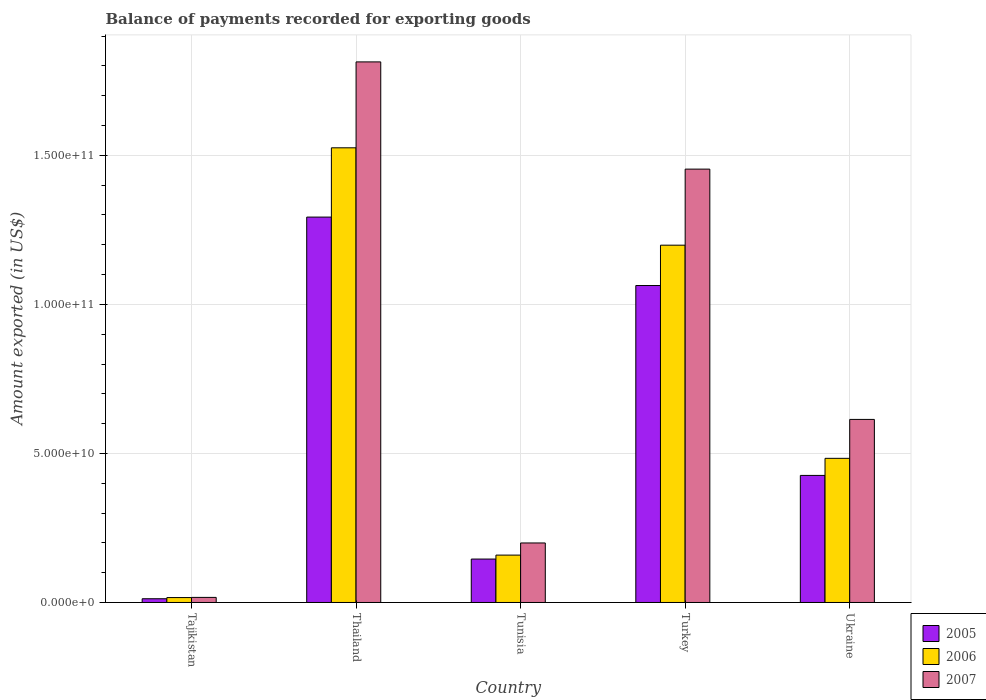How many groups of bars are there?
Offer a very short reply. 5. Are the number of bars on each tick of the X-axis equal?
Your answer should be compact. Yes. How many bars are there on the 1st tick from the left?
Offer a terse response. 3. How many bars are there on the 5th tick from the right?
Your answer should be very brief. 3. What is the label of the 4th group of bars from the left?
Offer a terse response. Turkey. What is the amount exported in 2006 in Tunisia?
Your answer should be compact. 1.59e+1. Across all countries, what is the maximum amount exported in 2007?
Offer a terse response. 1.81e+11. Across all countries, what is the minimum amount exported in 2005?
Your answer should be very brief. 1.25e+09. In which country was the amount exported in 2006 maximum?
Ensure brevity in your answer.  Thailand. In which country was the amount exported in 2007 minimum?
Make the answer very short. Tajikistan. What is the total amount exported in 2005 in the graph?
Give a very brief answer. 2.94e+11. What is the difference between the amount exported in 2005 in Thailand and that in Ukraine?
Keep it short and to the point. 8.67e+1. What is the difference between the amount exported in 2006 in Ukraine and the amount exported in 2007 in Tunisia?
Give a very brief answer. 2.84e+1. What is the average amount exported in 2006 per country?
Offer a very short reply. 6.77e+1. What is the difference between the amount exported of/in 2007 and amount exported of/in 2005 in Thailand?
Your answer should be compact. 5.21e+1. In how many countries, is the amount exported in 2006 greater than 40000000000 US$?
Give a very brief answer. 3. What is the ratio of the amount exported in 2006 in Tunisia to that in Ukraine?
Provide a succinct answer. 0.33. Is the difference between the amount exported in 2007 in Tajikistan and Tunisia greater than the difference between the amount exported in 2005 in Tajikistan and Tunisia?
Ensure brevity in your answer.  No. What is the difference between the highest and the second highest amount exported in 2006?
Provide a succinct answer. 3.27e+1. What is the difference between the highest and the lowest amount exported in 2006?
Your answer should be compact. 1.51e+11. In how many countries, is the amount exported in 2005 greater than the average amount exported in 2005 taken over all countries?
Keep it short and to the point. 2. What does the 2nd bar from the left in Turkey represents?
Your answer should be very brief. 2006. What does the 2nd bar from the right in Thailand represents?
Keep it short and to the point. 2006. How many countries are there in the graph?
Your answer should be compact. 5. Are the values on the major ticks of Y-axis written in scientific E-notation?
Offer a terse response. Yes. How many legend labels are there?
Your answer should be very brief. 3. What is the title of the graph?
Provide a succinct answer. Balance of payments recorded for exporting goods. What is the label or title of the Y-axis?
Your answer should be compact. Amount exported (in US$). What is the Amount exported (in US$) of 2005 in Tajikistan?
Keep it short and to the point. 1.25e+09. What is the Amount exported (in US$) in 2006 in Tajikistan?
Offer a very short reply. 1.65e+09. What is the Amount exported (in US$) in 2007 in Tajikistan?
Give a very brief answer. 1.71e+09. What is the Amount exported (in US$) in 2005 in Thailand?
Provide a succinct answer. 1.29e+11. What is the Amount exported (in US$) in 2006 in Thailand?
Provide a succinct answer. 1.53e+11. What is the Amount exported (in US$) in 2007 in Thailand?
Provide a short and direct response. 1.81e+11. What is the Amount exported (in US$) in 2005 in Tunisia?
Your response must be concise. 1.46e+1. What is the Amount exported (in US$) in 2006 in Tunisia?
Make the answer very short. 1.59e+1. What is the Amount exported (in US$) of 2007 in Tunisia?
Offer a very short reply. 2.00e+1. What is the Amount exported (in US$) of 2005 in Turkey?
Keep it short and to the point. 1.06e+11. What is the Amount exported (in US$) of 2006 in Turkey?
Offer a terse response. 1.20e+11. What is the Amount exported (in US$) in 2007 in Turkey?
Provide a short and direct response. 1.45e+11. What is the Amount exported (in US$) in 2005 in Ukraine?
Ensure brevity in your answer.  4.26e+1. What is the Amount exported (in US$) in 2006 in Ukraine?
Ensure brevity in your answer.  4.84e+1. What is the Amount exported (in US$) in 2007 in Ukraine?
Ensure brevity in your answer.  6.14e+1. Across all countries, what is the maximum Amount exported (in US$) of 2005?
Provide a succinct answer. 1.29e+11. Across all countries, what is the maximum Amount exported (in US$) of 2006?
Offer a very short reply. 1.53e+11. Across all countries, what is the maximum Amount exported (in US$) in 2007?
Your response must be concise. 1.81e+11. Across all countries, what is the minimum Amount exported (in US$) in 2005?
Offer a terse response. 1.25e+09. Across all countries, what is the minimum Amount exported (in US$) of 2006?
Offer a terse response. 1.65e+09. Across all countries, what is the minimum Amount exported (in US$) of 2007?
Provide a short and direct response. 1.71e+09. What is the total Amount exported (in US$) of 2005 in the graph?
Offer a very short reply. 2.94e+11. What is the total Amount exported (in US$) in 2006 in the graph?
Your response must be concise. 3.38e+11. What is the total Amount exported (in US$) in 2007 in the graph?
Offer a very short reply. 4.10e+11. What is the difference between the Amount exported (in US$) of 2005 in Tajikistan and that in Thailand?
Provide a succinct answer. -1.28e+11. What is the difference between the Amount exported (in US$) in 2006 in Tajikistan and that in Thailand?
Provide a short and direct response. -1.51e+11. What is the difference between the Amount exported (in US$) of 2007 in Tajikistan and that in Thailand?
Make the answer very short. -1.80e+11. What is the difference between the Amount exported (in US$) of 2005 in Tajikistan and that in Tunisia?
Keep it short and to the point. -1.33e+1. What is the difference between the Amount exported (in US$) of 2006 in Tajikistan and that in Tunisia?
Make the answer very short. -1.42e+1. What is the difference between the Amount exported (in US$) of 2007 in Tajikistan and that in Tunisia?
Keep it short and to the point. -1.83e+1. What is the difference between the Amount exported (in US$) in 2005 in Tajikistan and that in Turkey?
Your answer should be compact. -1.05e+11. What is the difference between the Amount exported (in US$) in 2006 in Tajikistan and that in Turkey?
Your answer should be very brief. -1.18e+11. What is the difference between the Amount exported (in US$) of 2007 in Tajikistan and that in Turkey?
Offer a very short reply. -1.44e+11. What is the difference between the Amount exported (in US$) in 2005 in Tajikistan and that in Ukraine?
Provide a succinct answer. -4.14e+1. What is the difference between the Amount exported (in US$) of 2006 in Tajikistan and that in Ukraine?
Your answer should be very brief. -4.67e+1. What is the difference between the Amount exported (in US$) in 2007 in Tajikistan and that in Ukraine?
Provide a succinct answer. -5.97e+1. What is the difference between the Amount exported (in US$) in 2005 in Thailand and that in Tunisia?
Offer a very short reply. 1.15e+11. What is the difference between the Amount exported (in US$) of 2006 in Thailand and that in Tunisia?
Your answer should be compact. 1.37e+11. What is the difference between the Amount exported (in US$) of 2007 in Thailand and that in Tunisia?
Provide a succinct answer. 1.61e+11. What is the difference between the Amount exported (in US$) in 2005 in Thailand and that in Turkey?
Offer a very short reply. 2.30e+1. What is the difference between the Amount exported (in US$) of 2006 in Thailand and that in Turkey?
Give a very brief answer. 3.27e+1. What is the difference between the Amount exported (in US$) of 2007 in Thailand and that in Turkey?
Give a very brief answer. 3.60e+1. What is the difference between the Amount exported (in US$) in 2005 in Thailand and that in Ukraine?
Provide a short and direct response. 8.67e+1. What is the difference between the Amount exported (in US$) of 2006 in Thailand and that in Ukraine?
Offer a terse response. 1.04e+11. What is the difference between the Amount exported (in US$) in 2007 in Thailand and that in Ukraine?
Give a very brief answer. 1.20e+11. What is the difference between the Amount exported (in US$) in 2005 in Tunisia and that in Turkey?
Your response must be concise. -9.18e+1. What is the difference between the Amount exported (in US$) of 2006 in Tunisia and that in Turkey?
Provide a short and direct response. -1.04e+11. What is the difference between the Amount exported (in US$) in 2007 in Tunisia and that in Turkey?
Give a very brief answer. -1.25e+11. What is the difference between the Amount exported (in US$) of 2005 in Tunisia and that in Ukraine?
Your answer should be compact. -2.81e+1. What is the difference between the Amount exported (in US$) of 2006 in Tunisia and that in Ukraine?
Offer a terse response. -3.25e+1. What is the difference between the Amount exported (in US$) of 2007 in Tunisia and that in Ukraine?
Provide a short and direct response. -4.14e+1. What is the difference between the Amount exported (in US$) in 2005 in Turkey and that in Ukraine?
Offer a terse response. 6.37e+1. What is the difference between the Amount exported (in US$) of 2006 in Turkey and that in Ukraine?
Your response must be concise. 7.15e+1. What is the difference between the Amount exported (in US$) of 2007 in Turkey and that in Ukraine?
Give a very brief answer. 8.40e+1. What is the difference between the Amount exported (in US$) of 2005 in Tajikistan and the Amount exported (in US$) of 2006 in Thailand?
Your answer should be compact. -1.51e+11. What is the difference between the Amount exported (in US$) of 2005 in Tajikistan and the Amount exported (in US$) of 2007 in Thailand?
Ensure brevity in your answer.  -1.80e+11. What is the difference between the Amount exported (in US$) of 2006 in Tajikistan and the Amount exported (in US$) of 2007 in Thailand?
Provide a succinct answer. -1.80e+11. What is the difference between the Amount exported (in US$) in 2005 in Tajikistan and the Amount exported (in US$) in 2006 in Tunisia?
Your response must be concise. -1.46e+1. What is the difference between the Amount exported (in US$) of 2005 in Tajikistan and the Amount exported (in US$) of 2007 in Tunisia?
Ensure brevity in your answer.  -1.87e+1. What is the difference between the Amount exported (in US$) of 2006 in Tajikistan and the Amount exported (in US$) of 2007 in Tunisia?
Ensure brevity in your answer.  -1.83e+1. What is the difference between the Amount exported (in US$) in 2005 in Tajikistan and the Amount exported (in US$) in 2006 in Turkey?
Give a very brief answer. -1.19e+11. What is the difference between the Amount exported (in US$) of 2005 in Tajikistan and the Amount exported (in US$) of 2007 in Turkey?
Keep it short and to the point. -1.44e+11. What is the difference between the Amount exported (in US$) of 2006 in Tajikistan and the Amount exported (in US$) of 2007 in Turkey?
Keep it short and to the point. -1.44e+11. What is the difference between the Amount exported (in US$) in 2005 in Tajikistan and the Amount exported (in US$) in 2006 in Ukraine?
Your response must be concise. -4.71e+1. What is the difference between the Amount exported (in US$) of 2005 in Tajikistan and the Amount exported (in US$) of 2007 in Ukraine?
Offer a terse response. -6.02e+1. What is the difference between the Amount exported (in US$) in 2006 in Tajikistan and the Amount exported (in US$) in 2007 in Ukraine?
Your response must be concise. -5.98e+1. What is the difference between the Amount exported (in US$) of 2005 in Thailand and the Amount exported (in US$) of 2006 in Tunisia?
Your response must be concise. 1.13e+11. What is the difference between the Amount exported (in US$) of 2005 in Thailand and the Amount exported (in US$) of 2007 in Tunisia?
Your response must be concise. 1.09e+11. What is the difference between the Amount exported (in US$) of 2006 in Thailand and the Amount exported (in US$) of 2007 in Tunisia?
Your answer should be very brief. 1.33e+11. What is the difference between the Amount exported (in US$) of 2005 in Thailand and the Amount exported (in US$) of 2006 in Turkey?
Keep it short and to the point. 9.43e+09. What is the difference between the Amount exported (in US$) in 2005 in Thailand and the Amount exported (in US$) in 2007 in Turkey?
Provide a succinct answer. -1.61e+1. What is the difference between the Amount exported (in US$) in 2006 in Thailand and the Amount exported (in US$) in 2007 in Turkey?
Ensure brevity in your answer.  7.15e+09. What is the difference between the Amount exported (in US$) in 2005 in Thailand and the Amount exported (in US$) in 2006 in Ukraine?
Offer a terse response. 8.09e+1. What is the difference between the Amount exported (in US$) of 2005 in Thailand and the Amount exported (in US$) of 2007 in Ukraine?
Give a very brief answer. 6.79e+1. What is the difference between the Amount exported (in US$) of 2006 in Thailand and the Amount exported (in US$) of 2007 in Ukraine?
Your response must be concise. 9.11e+1. What is the difference between the Amount exported (in US$) in 2005 in Tunisia and the Amount exported (in US$) in 2006 in Turkey?
Provide a succinct answer. -1.05e+11. What is the difference between the Amount exported (in US$) in 2005 in Tunisia and the Amount exported (in US$) in 2007 in Turkey?
Your answer should be compact. -1.31e+11. What is the difference between the Amount exported (in US$) in 2006 in Tunisia and the Amount exported (in US$) in 2007 in Turkey?
Your answer should be very brief. -1.29e+11. What is the difference between the Amount exported (in US$) in 2005 in Tunisia and the Amount exported (in US$) in 2006 in Ukraine?
Your answer should be very brief. -3.38e+1. What is the difference between the Amount exported (in US$) of 2005 in Tunisia and the Amount exported (in US$) of 2007 in Ukraine?
Give a very brief answer. -4.68e+1. What is the difference between the Amount exported (in US$) of 2006 in Tunisia and the Amount exported (in US$) of 2007 in Ukraine?
Provide a succinct answer. -4.55e+1. What is the difference between the Amount exported (in US$) of 2005 in Turkey and the Amount exported (in US$) of 2006 in Ukraine?
Offer a very short reply. 5.80e+1. What is the difference between the Amount exported (in US$) in 2005 in Turkey and the Amount exported (in US$) in 2007 in Ukraine?
Provide a short and direct response. 4.49e+1. What is the difference between the Amount exported (in US$) of 2006 in Turkey and the Amount exported (in US$) of 2007 in Ukraine?
Make the answer very short. 5.85e+1. What is the average Amount exported (in US$) of 2005 per country?
Your answer should be very brief. 5.88e+1. What is the average Amount exported (in US$) of 2006 per country?
Keep it short and to the point. 6.77e+1. What is the average Amount exported (in US$) in 2007 per country?
Ensure brevity in your answer.  8.20e+1. What is the difference between the Amount exported (in US$) of 2005 and Amount exported (in US$) of 2006 in Tajikistan?
Give a very brief answer. -3.92e+08. What is the difference between the Amount exported (in US$) in 2005 and Amount exported (in US$) in 2007 in Tajikistan?
Provide a succinct answer. -4.51e+08. What is the difference between the Amount exported (in US$) in 2006 and Amount exported (in US$) in 2007 in Tajikistan?
Provide a succinct answer. -5.96e+07. What is the difference between the Amount exported (in US$) in 2005 and Amount exported (in US$) in 2006 in Thailand?
Make the answer very short. -2.32e+1. What is the difference between the Amount exported (in US$) of 2005 and Amount exported (in US$) of 2007 in Thailand?
Your answer should be very brief. -5.21e+1. What is the difference between the Amount exported (in US$) in 2006 and Amount exported (in US$) in 2007 in Thailand?
Your answer should be very brief. -2.88e+1. What is the difference between the Amount exported (in US$) in 2005 and Amount exported (in US$) in 2006 in Tunisia?
Keep it short and to the point. -1.32e+09. What is the difference between the Amount exported (in US$) in 2005 and Amount exported (in US$) in 2007 in Tunisia?
Your response must be concise. -5.40e+09. What is the difference between the Amount exported (in US$) in 2006 and Amount exported (in US$) in 2007 in Tunisia?
Keep it short and to the point. -4.07e+09. What is the difference between the Amount exported (in US$) of 2005 and Amount exported (in US$) of 2006 in Turkey?
Keep it short and to the point. -1.35e+1. What is the difference between the Amount exported (in US$) in 2005 and Amount exported (in US$) in 2007 in Turkey?
Give a very brief answer. -3.91e+1. What is the difference between the Amount exported (in US$) in 2006 and Amount exported (in US$) in 2007 in Turkey?
Provide a short and direct response. -2.55e+1. What is the difference between the Amount exported (in US$) in 2005 and Amount exported (in US$) in 2006 in Ukraine?
Ensure brevity in your answer.  -5.73e+09. What is the difference between the Amount exported (in US$) of 2005 and Amount exported (in US$) of 2007 in Ukraine?
Your answer should be compact. -1.88e+1. What is the difference between the Amount exported (in US$) in 2006 and Amount exported (in US$) in 2007 in Ukraine?
Your answer should be very brief. -1.31e+1. What is the ratio of the Amount exported (in US$) in 2005 in Tajikistan to that in Thailand?
Your answer should be compact. 0.01. What is the ratio of the Amount exported (in US$) of 2006 in Tajikistan to that in Thailand?
Offer a very short reply. 0.01. What is the ratio of the Amount exported (in US$) of 2007 in Tajikistan to that in Thailand?
Keep it short and to the point. 0.01. What is the ratio of the Amount exported (in US$) in 2005 in Tajikistan to that in Tunisia?
Keep it short and to the point. 0.09. What is the ratio of the Amount exported (in US$) in 2006 in Tajikistan to that in Tunisia?
Keep it short and to the point. 0.1. What is the ratio of the Amount exported (in US$) in 2007 in Tajikistan to that in Tunisia?
Make the answer very short. 0.09. What is the ratio of the Amount exported (in US$) of 2005 in Tajikistan to that in Turkey?
Your response must be concise. 0.01. What is the ratio of the Amount exported (in US$) in 2006 in Tajikistan to that in Turkey?
Give a very brief answer. 0.01. What is the ratio of the Amount exported (in US$) of 2007 in Tajikistan to that in Turkey?
Offer a very short reply. 0.01. What is the ratio of the Amount exported (in US$) in 2005 in Tajikistan to that in Ukraine?
Keep it short and to the point. 0.03. What is the ratio of the Amount exported (in US$) of 2006 in Tajikistan to that in Ukraine?
Your response must be concise. 0.03. What is the ratio of the Amount exported (in US$) in 2007 in Tajikistan to that in Ukraine?
Give a very brief answer. 0.03. What is the ratio of the Amount exported (in US$) of 2005 in Thailand to that in Tunisia?
Your answer should be compact. 8.88. What is the ratio of the Amount exported (in US$) in 2006 in Thailand to that in Tunisia?
Make the answer very short. 9.6. What is the ratio of the Amount exported (in US$) in 2007 in Thailand to that in Tunisia?
Provide a succinct answer. 9.08. What is the ratio of the Amount exported (in US$) in 2005 in Thailand to that in Turkey?
Your response must be concise. 1.22. What is the ratio of the Amount exported (in US$) of 2006 in Thailand to that in Turkey?
Keep it short and to the point. 1.27. What is the ratio of the Amount exported (in US$) in 2007 in Thailand to that in Turkey?
Provide a short and direct response. 1.25. What is the ratio of the Amount exported (in US$) of 2005 in Thailand to that in Ukraine?
Keep it short and to the point. 3.03. What is the ratio of the Amount exported (in US$) in 2006 in Thailand to that in Ukraine?
Ensure brevity in your answer.  3.15. What is the ratio of the Amount exported (in US$) in 2007 in Thailand to that in Ukraine?
Your answer should be very brief. 2.95. What is the ratio of the Amount exported (in US$) of 2005 in Tunisia to that in Turkey?
Offer a very short reply. 0.14. What is the ratio of the Amount exported (in US$) in 2006 in Tunisia to that in Turkey?
Provide a succinct answer. 0.13. What is the ratio of the Amount exported (in US$) in 2007 in Tunisia to that in Turkey?
Ensure brevity in your answer.  0.14. What is the ratio of the Amount exported (in US$) in 2005 in Tunisia to that in Ukraine?
Your answer should be very brief. 0.34. What is the ratio of the Amount exported (in US$) of 2006 in Tunisia to that in Ukraine?
Offer a very short reply. 0.33. What is the ratio of the Amount exported (in US$) of 2007 in Tunisia to that in Ukraine?
Make the answer very short. 0.33. What is the ratio of the Amount exported (in US$) of 2005 in Turkey to that in Ukraine?
Keep it short and to the point. 2.49. What is the ratio of the Amount exported (in US$) of 2006 in Turkey to that in Ukraine?
Ensure brevity in your answer.  2.48. What is the ratio of the Amount exported (in US$) of 2007 in Turkey to that in Ukraine?
Make the answer very short. 2.37. What is the difference between the highest and the second highest Amount exported (in US$) of 2005?
Ensure brevity in your answer.  2.30e+1. What is the difference between the highest and the second highest Amount exported (in US$) in 2006?
Give a very brief answer. 3.27e+1. What is the difference between the highest and the second highest Amount exported (in US$) in 2007?
Your answer should be very brief. 3.60e+1. What is the difference between the highest and the lowest Amount exported (in US$) in 2005?
Your response must be concise. 1.28e+11. What is the difference between the highest and the lowest Amount exported (in US$) of 2006?
Provide a short and direct response. 1.51e+11. What is the difference between the highest and the lowest Amount exported (in US$) of 2007?
Give a very brief answer. 1.80e+11. 